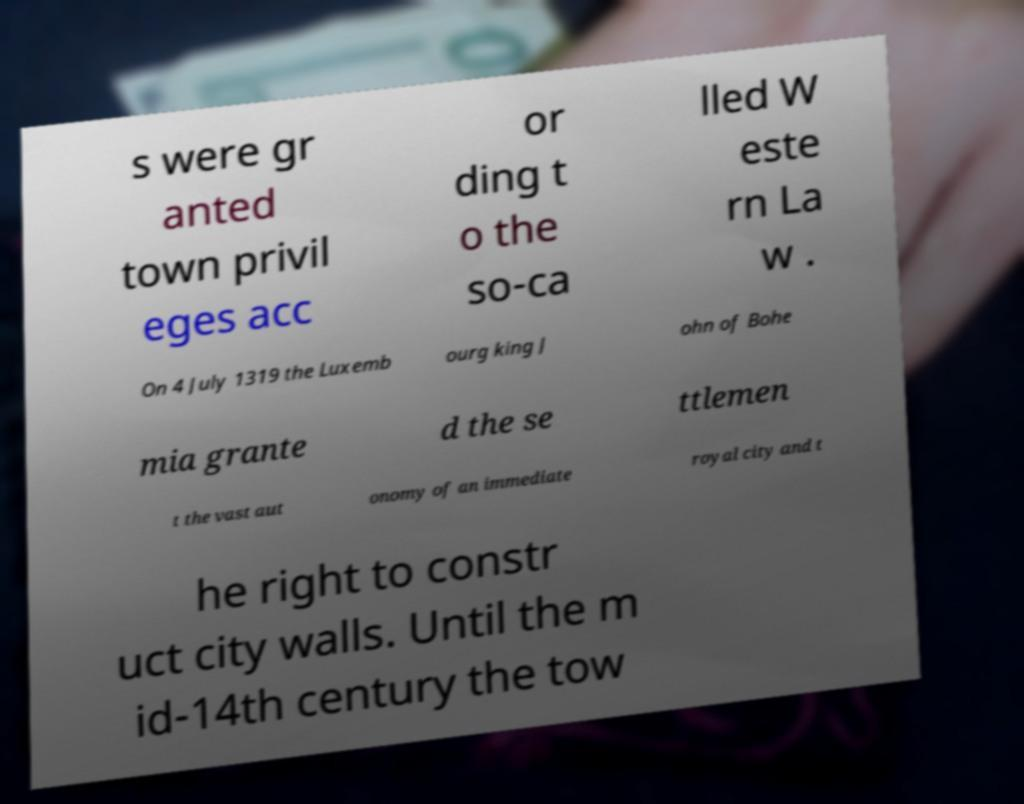I need the written content from this picture converted into text. Can you do that? s were gr anted town privil eges acc or ding t o the so-ca lled W este rn La w . On 4 July 1319 the Luxemb ourg king J ohn of Bohe mia grante d the se ttlemen t the vast aut onomy of an immediate royal city and t he right to constr uct city walls. Until the m id-14th century the tow 